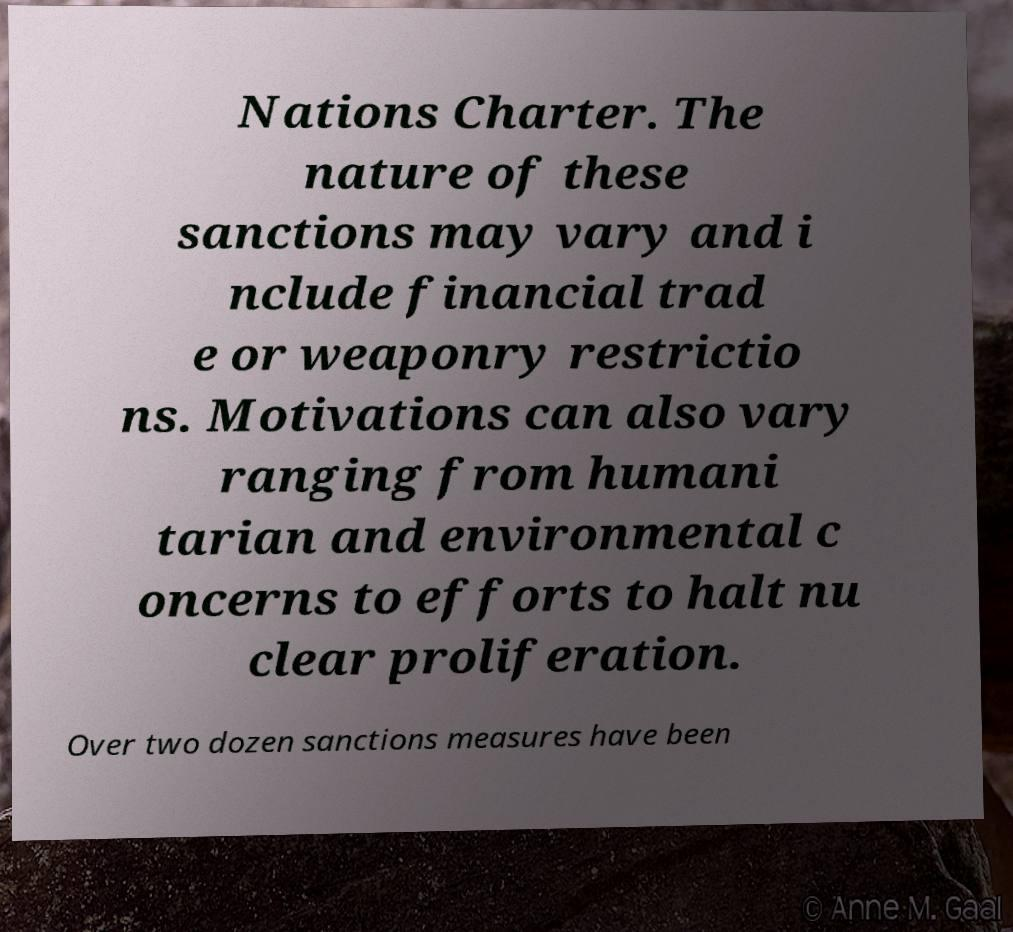There's text embedded in this image that I need extracted. Can you transcribe it verbatim? Nations Charter. The nature of these sanctions may vary and i nclude financial trad e or weaponry restrictio ns. Motivations can also vary ranging from humani tarian and environmental c oncerns to efforts to halt nu clear proliferation. Over two dozen sanctions measures have been 